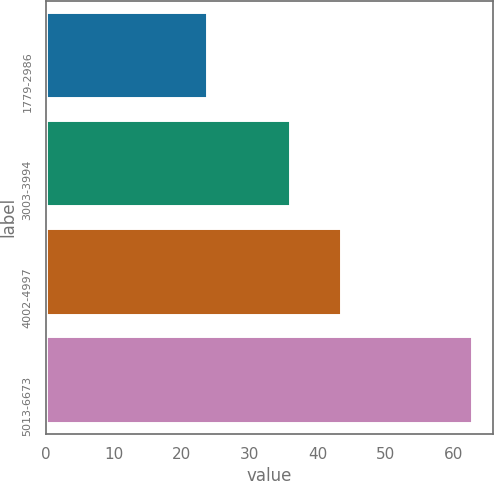Convert chart. <chart><loc_0><loc_0><loc_500><loc_500><bar_chart><fcel>1779-2986<fcel>3003-3994<fcel>4002-4997<fcel>5013-6673<nl><fcel>23.67<fcel>35.9<fcel>43.47<fcel>62.62<nl></chart> 